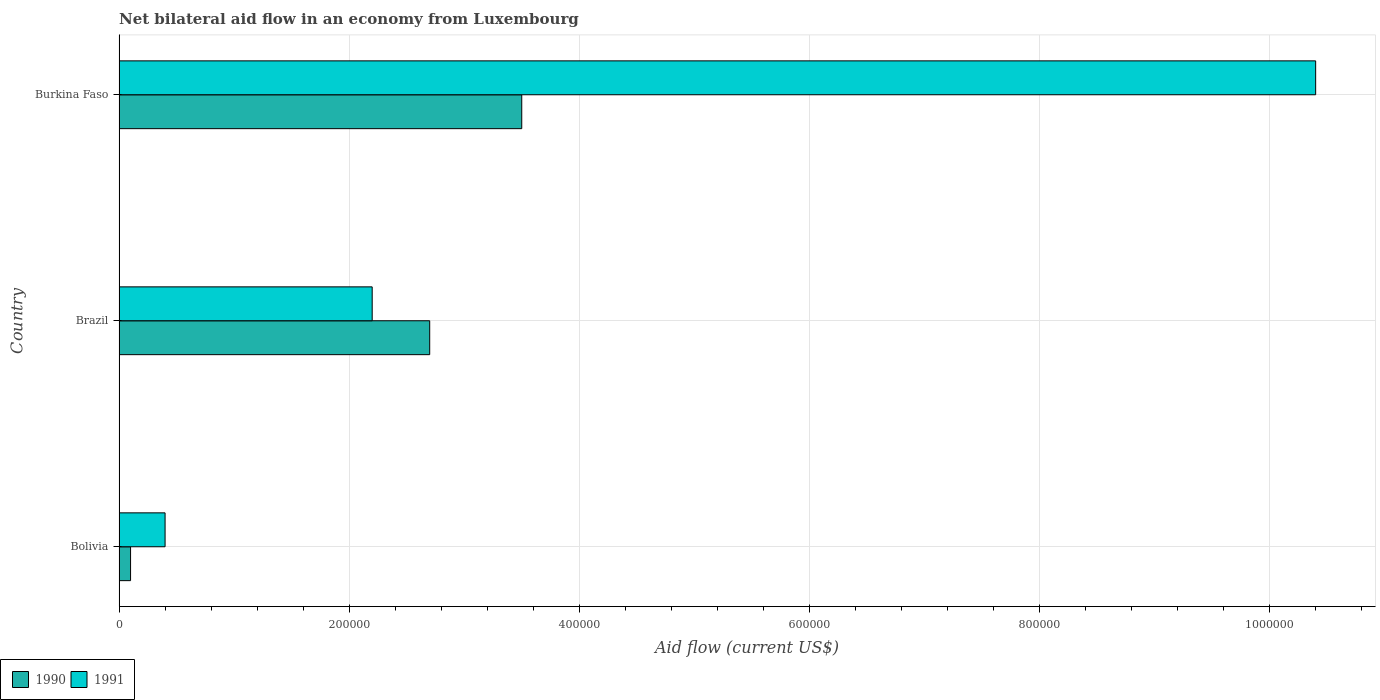How many groups of bars are there?
Offer a very short reply. 3. Are the number of bars per tick equal to the number of legend labels?
Provide a short and direct response. Yes. Are the number of bars on each tick of the Y-axis equal?
Your response must be concise. Yes. How many bars are there on the 3rd tick from the bottom?
Your answer should be very brief. 2. In how many cases, is the number of bars for a given country not equal to the number of legend labels?
Ensure brevity in your answer.  0. What is the net bilateral aid flow in 1990 in Burkina Faso?
Provide a succinct answer. 3.50e+05. Across all countries, what is the maximum net bilateral aid flow in 1991?
Keep it short and to the point. 1.04e+06. In which country was the net bilateral aid flow in 1990 maximum?
Keep it short and to the point. Burkina Faso. What is the total net bilateral aid flow in 1991 in the graph?
Keep it short and to the point. 1.30e+06. What is the difference between the net bilateral aid flow in 1990 in Bolivia and that in Burkina Faso?
Provide a short and direct response. -3.40e+05. What is the difference between the net bilateral aid flow in 1991 in Burkina Faso and the net bilateral aid flow in 1990 in Bolivia?
Keep it short and to the point. 1.03e+06. What is the average net bilateral aid flow in 1991 per country?
Give a very brief answer. 4.33e+05. What is the difference between the net bilateral aid flow in 1991 and net bilateral aid flow in 1990 in Burkina Faso?
Your response must be concise. 6.90e+05. What is the ratio of the net bilateral aid flow in 1990 in Brazil to that in Burkina Faso?
Keep it short and to the point. 0.77. Is the net bilateral aid flow in 1990 in Brazil less than that in Burkina Faso?
Provide a short and direct response. Yes. What is the difference between the highest and the second highest net bilateral aid flow in 1991?
Your answer should be compact. 8.20e+05. Is the sum of the net bilateral aid flow in 1990 in Bolivia and Burkina Faso greater than the maximum net bilateral aid flow in 1991 across all countries?
Offer a terse response. No. What does the 1st bar from the bottom in Brazil represents?
Your answer should be very brief. 1990. How many bars are there?
Provide a short and direct response. 6. Are all the bars in the graph horizontal?
Give a very brief answer. Yes. How many countries are there in the graph?
Keep it short and to the point. 3. What is the title of the graph?
Offer a terse response. Net bilateral aid flow in an economy from Luxembourg. Does "1962" appear as one of the legend labels in the graph?
Your response must be concise. No. What is the Aid flow (current US$) in 1990 in Bolivia?
Offer a very short reply. 10000. What is the Aid flow (current US$) of 1990 in Burkina Faso?
Provide a succinct answer. 3.50e+05. What is the Aid flow (current US$) in 1991 in Burkina Faso?
Offer a terse response. 1.04e+06. Across all countries, what is the maximum Aid flow (current US$) in 1990?
Provide a succinct answer. 3.50e+05. Across all countries, what is the maximum Aid flow (current US$) in 1991?
Offer a very short reply. 1.04e+06. Across all countries, what is the minimum Aid flow (current US$) in 1991?
Offer a terse response. 4.00e+04. What is the total Aid flow (current US$) in 1990 in the graph?
Provide a succinct answer. 6.30e+05. What is the total Aid flow (current US$) in 1991 in the graph?
Provide a short and direct response. 1.30e+06. What is the difference between the Aid flow (current US$) of 1990 in Bolivia and that in Brazil?
Keep it short and to the point. -2.60e+05. What is the difference between the Aid flow (current US$) in 1991 in Bolivia and that in Brazil?
Offer a very short reply. -1.80e+05. What is the difference between the Aid flow (current US$) of 1991 in Brazil and that in Burkina Faso?
Make the answer very short. -8.20e+05. What is the difference between the Aid flow (current US$) of 1990 in Bolivia and the Aid flow (current US$) of 1991 in Brazil?
Ensure brevity in your answer.  -2.10e+05. What is the difference between the Aid flow (current US$) in 1990 in Bolivia and the Aid flow (current US$) in 1991 in Burkina Faso?
Make the answer very short. -1.03e+06. What is the difference between the Aid flow (current US$) in 1990 in Brazil and the Aid flow (current US$) in 1991 in Burkina Faso?
Provide a succinct answer. -7.70e+05. What is the average Aid flow (current US$) of 1991 per country?
Ensure brevity in your answer.  4.33e+05. What is the difference between the Aid flow (current US$) in 1990 and Aid flow (current US$) in 1991 in Burkina Faso?
Provide a short and direct response. -6.90e+05. What is the ratio of the Aid flow (current US$) in 1990 in Bolivia to that in Brazil?
Make the answer very short. 0.04. What is the ratio of the Aid flow (current US$) of 1991 in Bolivia to that in Brazil?
Offer a very short reply. 0.18. What is the ratio of the Aid flow (current US$) in 1990 in Bolivia to that in Burkina Faso?
Give a very brief answer. 0.03. What is the ratio of the Aid flow (current US$) in 1991 in Bolivia to that in Burkina Faso?
Make the answer very short. 0.04. What is the ratio of the Aid flow (current US$) in 1990 in Brazil to that in Burkina Faso?
Offer a terse response. 0.77. What is the ratio of the Aid flow (current US$) in 1991 in Brazil to that in Burkina Faso?
Your response must be concise. 0.21. What is the difference between the highest and the second highest Aid flow (current US$) of 1990?
Provide a succinct answer. 8.00e+04. What is the difference between the highest and the second highest Aid flow (current US$) of 1991?
Ensure brevity in your answer.  8.20e+05. What is the difference between the highest and the lowest Aid flow (current US$) of 1991?
Provide a short and direct response. 1.00e+06. 